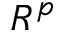<formula> <loc_0><loc_0><loc_500><loc_500>R ^ { p }</formula> 